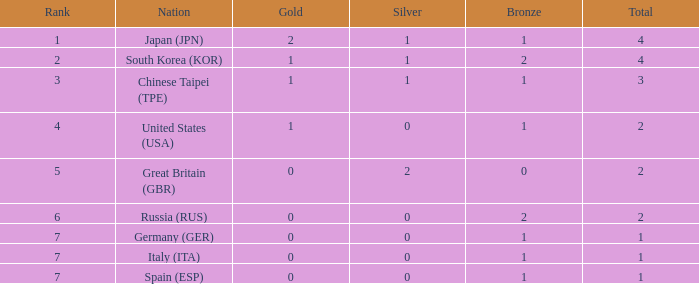What is the lowest quantity of gold for a nation at rank 6, possessing 2 bronzes? None. 